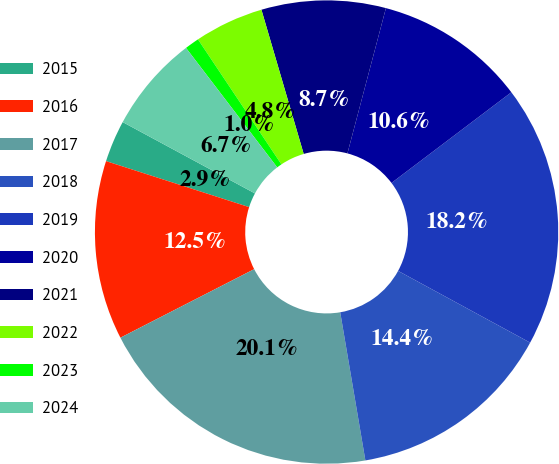Convert chart to OTSL. <chart><loc_0><loc_0><loc_500><loc_500><pie_chart><fcel>2015<fcel>2016<fcel>2017<fcel>2018<fcel>2019<fcel>2020<fcel>2021<fcel>2022<fcel>2023<fcel>2024<nl><fcel>2.92%<fcel>12.49%<fcel>20.14%<fcel>14.4%<fcel>18.23%<fcel>10.57%<fcel>8.66%<fcel>4.83%<fcel>1.01%<fcel>6.75%<nl></chart> 